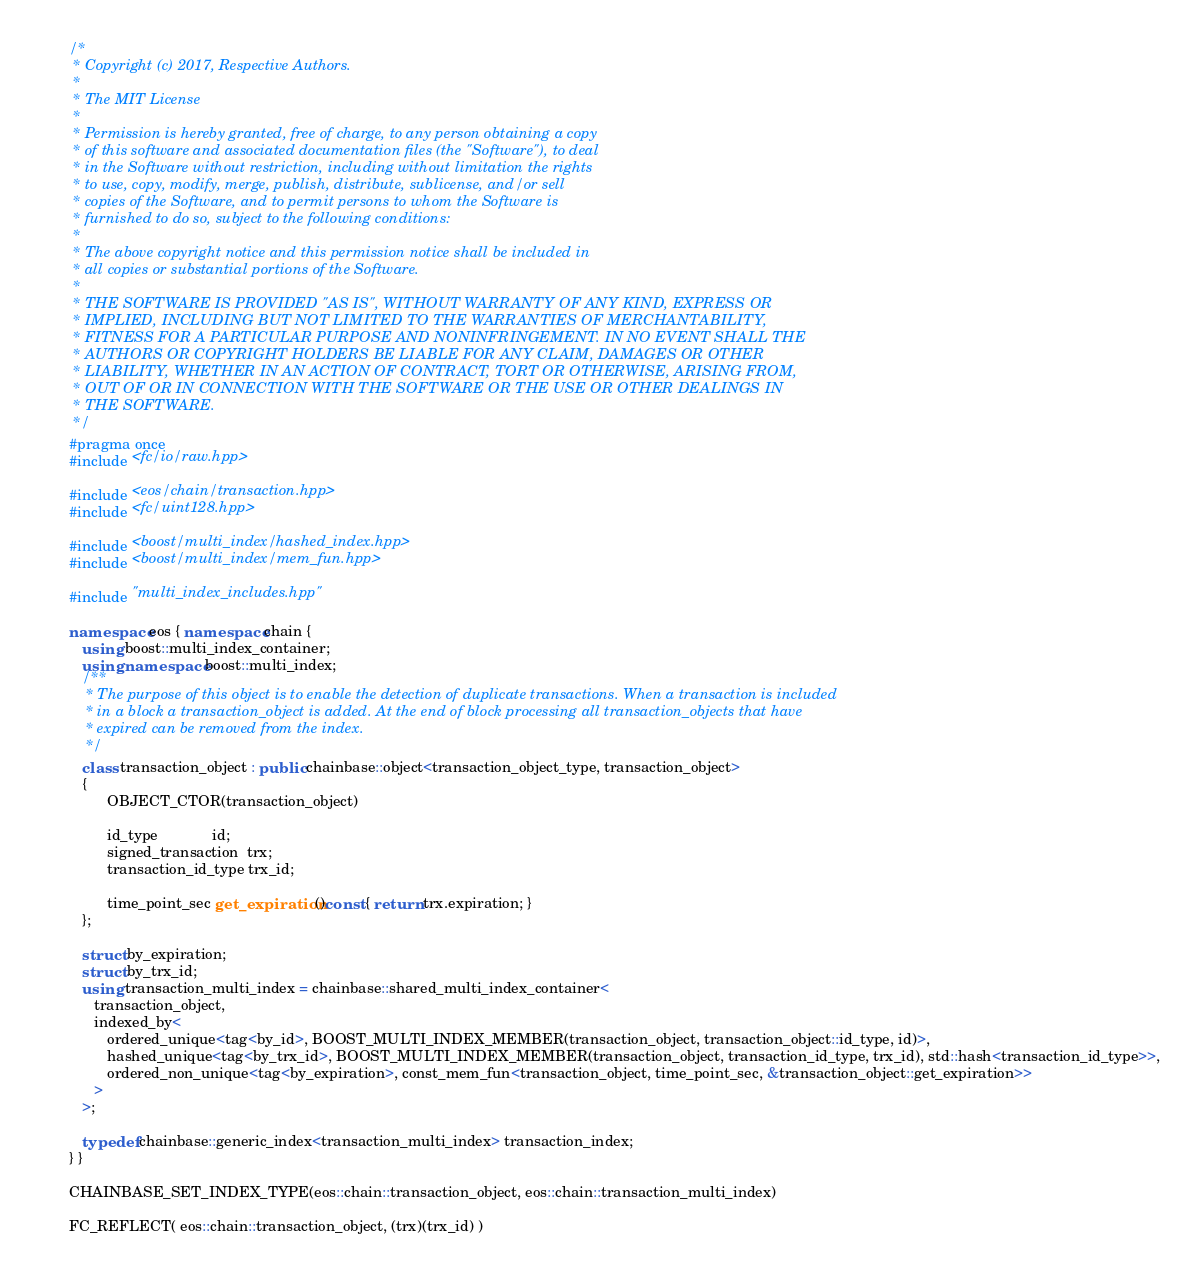Convert code to text. <code><loc_0><loc_0><loc_500><loc_500><_C++_>/*
 * Copyright (c) 2017, Respective Authors.
 *
 * The MIT License
 *
 * Permission is hereby granted, free of charge, to any person obtaining a copy
 * of this software and associated documentation files (the "Software"), to deal
 * in the Software without restriction, including without limitation the rights
 * to use, copy, modify, merge, publish, distribute, sublicense, and/or sell
 * copies of the Software, and to permit persons to whom the Software is
 * furnished to do so, subject to the following conditions:
 *
 * The above copyright notice and this permission notice shall be included in
 * all copies or substantial portions of the Software.
 *
 * THE SOFTWARE IS PROVIDED "AS IS", WITHOUT WARRANTY OF ANY KIND, EXPRESS OR
 * IMPLIED, INCLUDING BUT NOT LIMITED TO THE WARRANTIES OF MERCHANTABILITY,
 * FITNESS FOR A PARTICULAR PURPOSE AND NONINFRINGEMENT. IN NO EVENT SHALL THE
 * AUTHORS OR COPYRIGHT HOLDERS BE LIABLE FOR ANY CLAIM, DAMAGES OR OTHER
 * LIABILITY, WHETHER IN AN ACTION OF CONTRACT, TORT OR OTHERWISE, ARISING FROM,
 * OUT OF OR IN CONNECTION WITH THE SOFTWARE OR THE USE OR OTHER DEALINGS IN
 * THE SOFTWARE.
 */
#pragma once
#include <fc/io/raw.hpp>

#include <eos/chain/transaction.hpp>
#include <fc/uint128.hpp>

#include <boost/multi_index/hashed_index.hpp>
#include <boost/multi_index/mem_fun.hpp>

#include "multi_index_includes.hpp"

namespace eos { namespace chain {
   using boost::multi_index_container;
   using namespace boost::multi_index;
   /**
    * The purpose of this object is to enable the detection of duplicate transactions. When a transaction is included
    * in a block a transaction_object is added. At the end of block processing all transaction_objects that have
    * expired can be removed from the index.
    */
   class transaction_object : public chainbase::object<transaction_object_type, transaction_object>
   {
         OBJECT_CTOR(transaction_object)

         id_type             id;
         signed_transaction  trx;
         transaction_id_type trx_id;

         time_point_sec get_expiration()const { return trx.expiration; }
   };

   struct by_expiration;
   struct by_trx_id;
   using transaction_multi_index = chainbase::shared_multi_index_container<
      transaction_object,
      indexed_by<
         ordered_unique<tag<by_id>, BOOST_MULTI_INDEX_MEMBER(transaction_object, transaction_object::id_type, id)>,
         hashed_unique<tag<by_trx_id>, BOOST_MULTI_INDEX_MEMBER(transaction_object, transaction_id_type, trx_id), std::hash<transaction_id_type>>,
         ordered_non_unique<tag<by_expiration>, const_mem_fun<transaction_object, time_point_sec, &transaction_object::get_expiration>>
      >
   >;

   typedef chainbase::generic_index<transaction_multi_index> transaction_index;
} }

CHAINBASE_SET_INDEX_TYPE(eos::chain::transaction_object, eos::chain::transaction_multi_index)

FC_REFLECT( eos::chain::transaction_object, (trx)(trx_id) )
</code> 